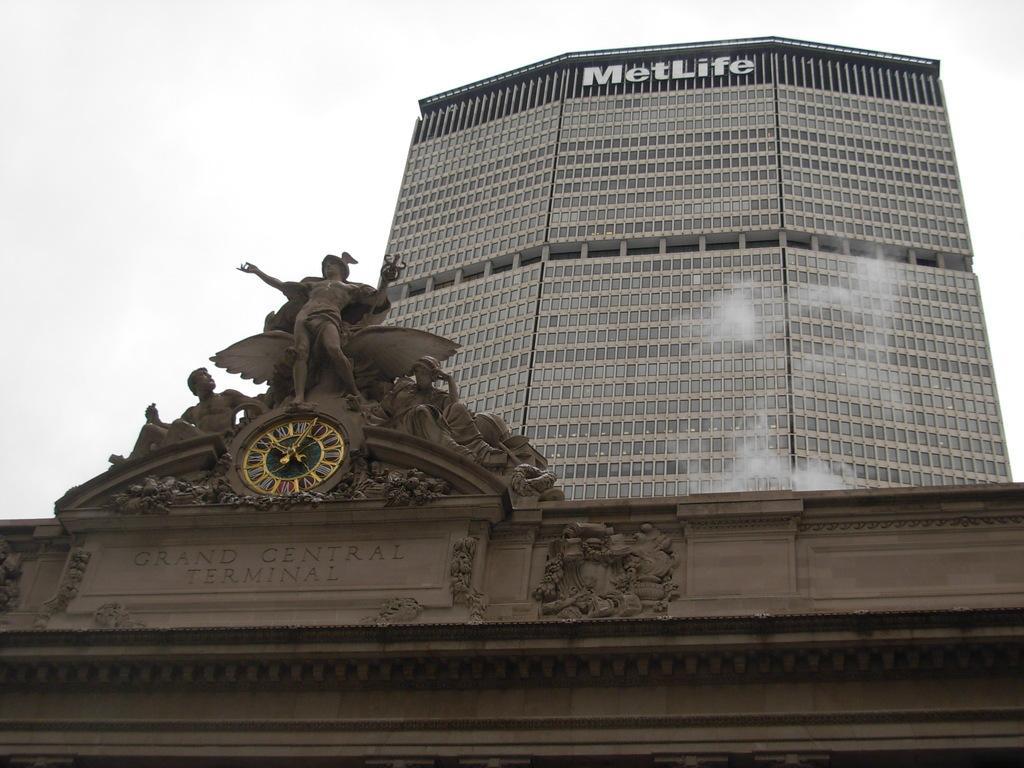Describe this image in one or two sentences. There are sculptures and a clock on the wall of a building. In the background, there is a hoarding on the wall of a building and there are clouds in the sky. 